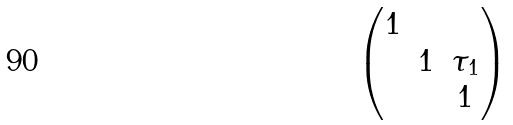Convert formula to latex. <formula><loc_0><loc_0><loc_500><loc_500>\begin{pmatrix} 1 & & \\ & 1 & \tau _ { 1 } \\ & & 1 \end{pmatrix}</formula> 